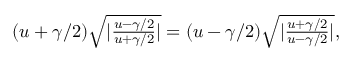<formula> <loc_0><loc_0><loc_500><loc_500>\begin{array} { r } { ( u + \gamma / 2 ) \sqrt { | \frac { u - \gamma / 2 } { u + \gamma / 2 } | } = ( u - \gamma / 2 ) \sqrt { | \frac { u + \gamma / 2 } { u - \gamma / 2 } | } , } \end{array}</formula> 